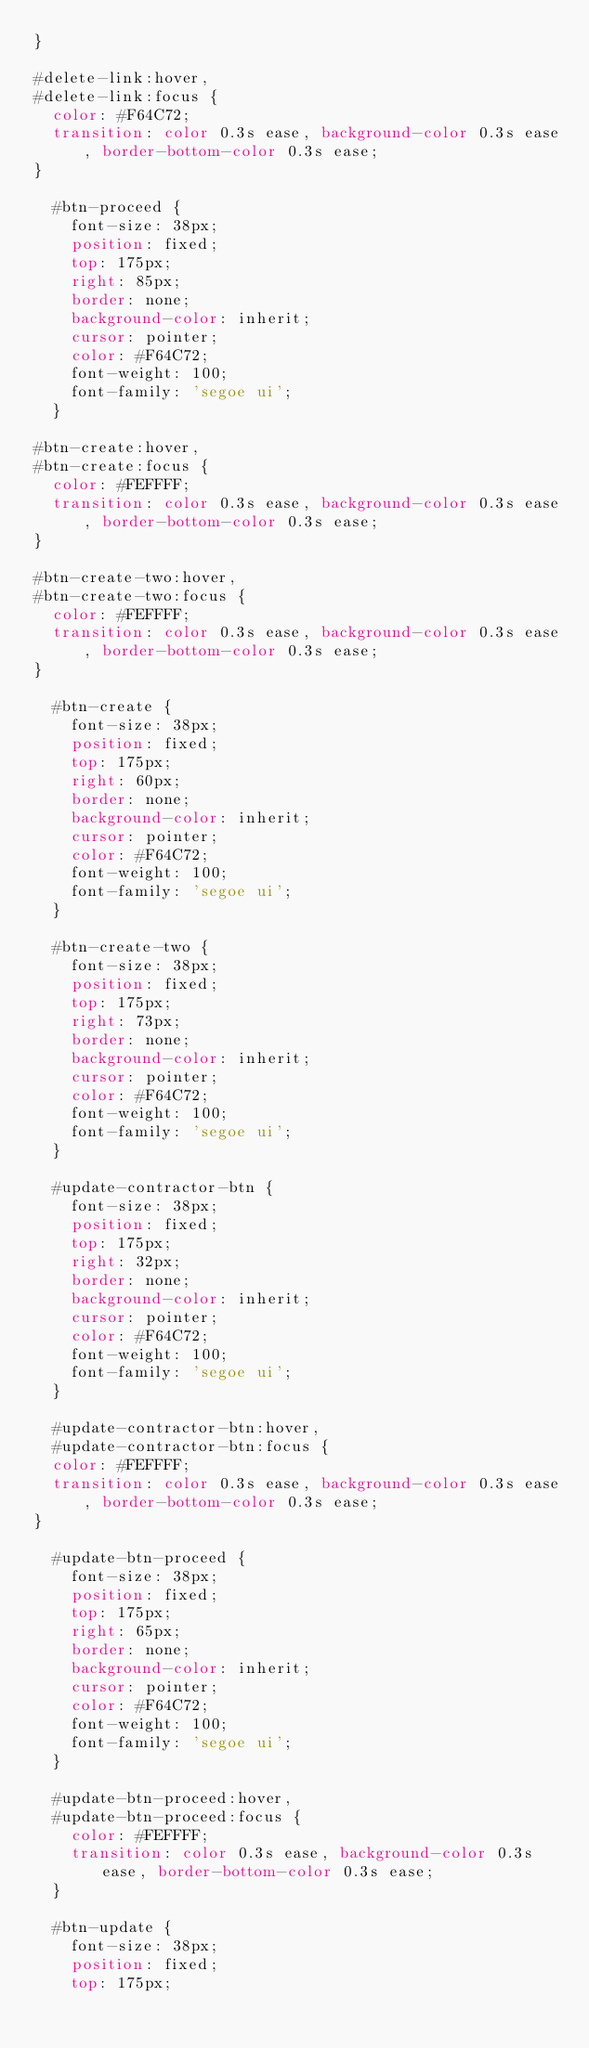<code> <loc_0><loc_0><loc_500><loc_500><_CSS_>}

#delete-link:hover,
#delete-link:focus {
  color: #F64C72;
  transition: color 0.3s ease, background-color 0.3s ease, border-bottom-color 0.3s ease;
}

  #btn-proceed {
    font-size: 38px;
    position: fixed;
    top: 175px;
    right: 85px;
    border: none;
    background-color: inherit;
    cursor: pointer;
    color: #F64C72;
    font-weight: 100;
    font-family: 'segoe ui';
  }

#btn-create:hover,
#btn-create:focus {
  color: #FEFFFF;
  transition: color 0.3s ease, background-color 0.3s ease, border-bottom-color 0.3s ease;
}

#btn-create-two:hover,
#btn-create-two:focus {
  color: #FEFFFF;
  transition: color 0.3s ease, background-color 0.3s ease, border-bottom-color 0.3s ease;
}

  #btn-create {
    font-size: 38px;
    position: fixed;
    top: 175px;
    right: 60px;
    border: none;
    background-color: inherit;
    cursor: pointer;
    color: #F64C72;
    font-weight: 100;
    font-family: 'segoe ui';
  }

  #btn-create-two {
    font-size: 38px;
    position: fixed;
    top: 175px;
    right: 73px;
    border: none;
    background-color: inherit;
    cursor: pointer;
    color: #F64C72;
    font-weight: 100;
    font-family: 'segoe ui';
  }

  #update-contractor-btn {
    font-size: 38px;
    position: fixed;
    top: 175px;
    right: 32px;
    border: none;
    background-color: inherit;
    cursor: pointer;
    color: #F64C72;
    font-weight: 100;
    font-family: 'segoe ui';
  }

  #update-contractor-btn:hover,
  #update-contractor-btn:focus {
  color: #FEFFFF;
  transition: color 0.3s ease, background-color 0.3s ease, border-bottom-color 0.3s ease;
}

  #update-btn-proceed {
    font-size: 38px;
    position: fixed;
    top: 175px;
    right: 65px;
    border: none;
    background-color: inherit;
    cursor: pointer;
    color: #F64C72;
    font-weight: 100;
    font-family: 'segoe ui';
  }

  #update-btn-proceed:hover,
  #update-btn-proceed:focus {
    color: #FEFFFF;
    transition: color 0.3s ease, background-color 0.3s ease, border-bottom-color 0.3s ease;
  }

  #btn-update {
    font-size: 38px;
    position: fixed;
    top: 175px;</code> 